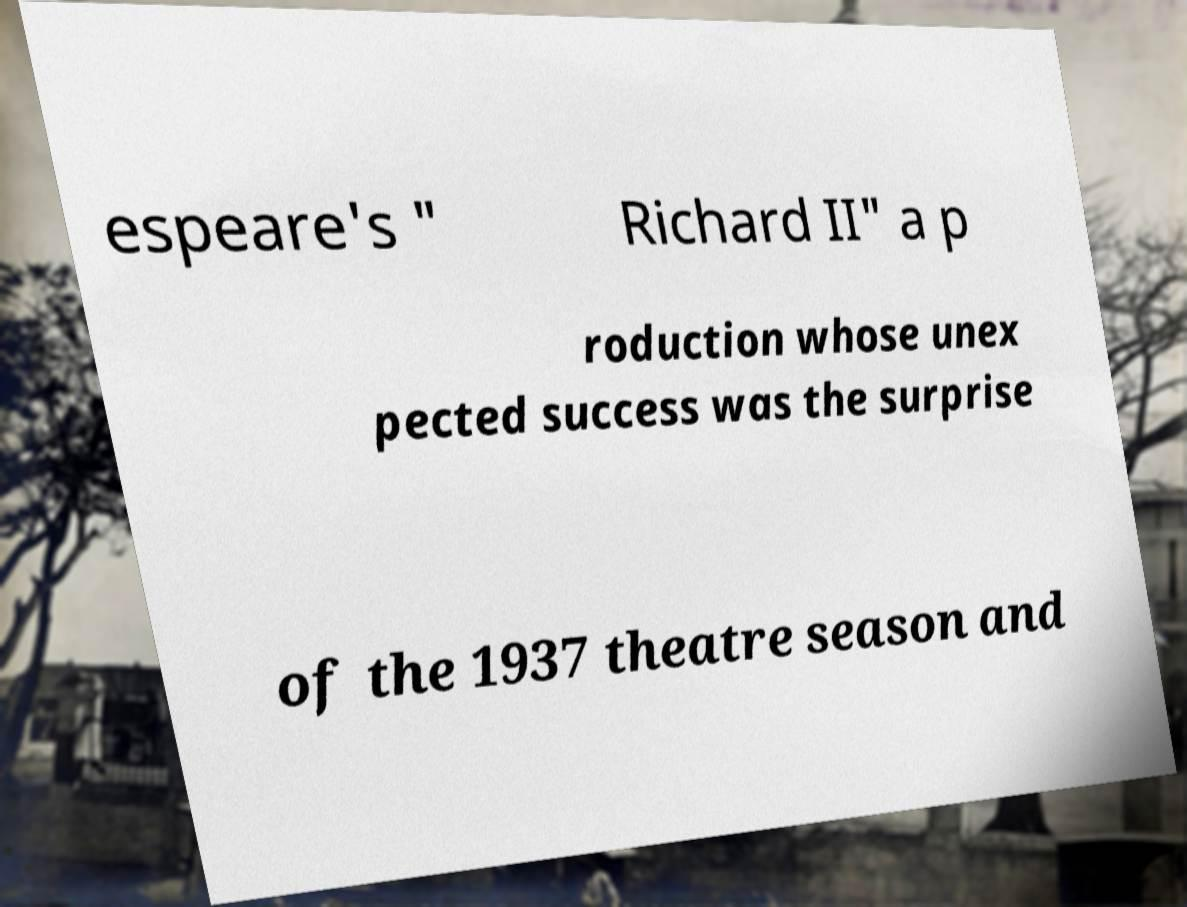For documentation purposes, I need the text within this image transcribed. Could you provide that? espeare's " Richard II" a p roduction whose unex pected success was the surprise of the 1937 theatre season and 